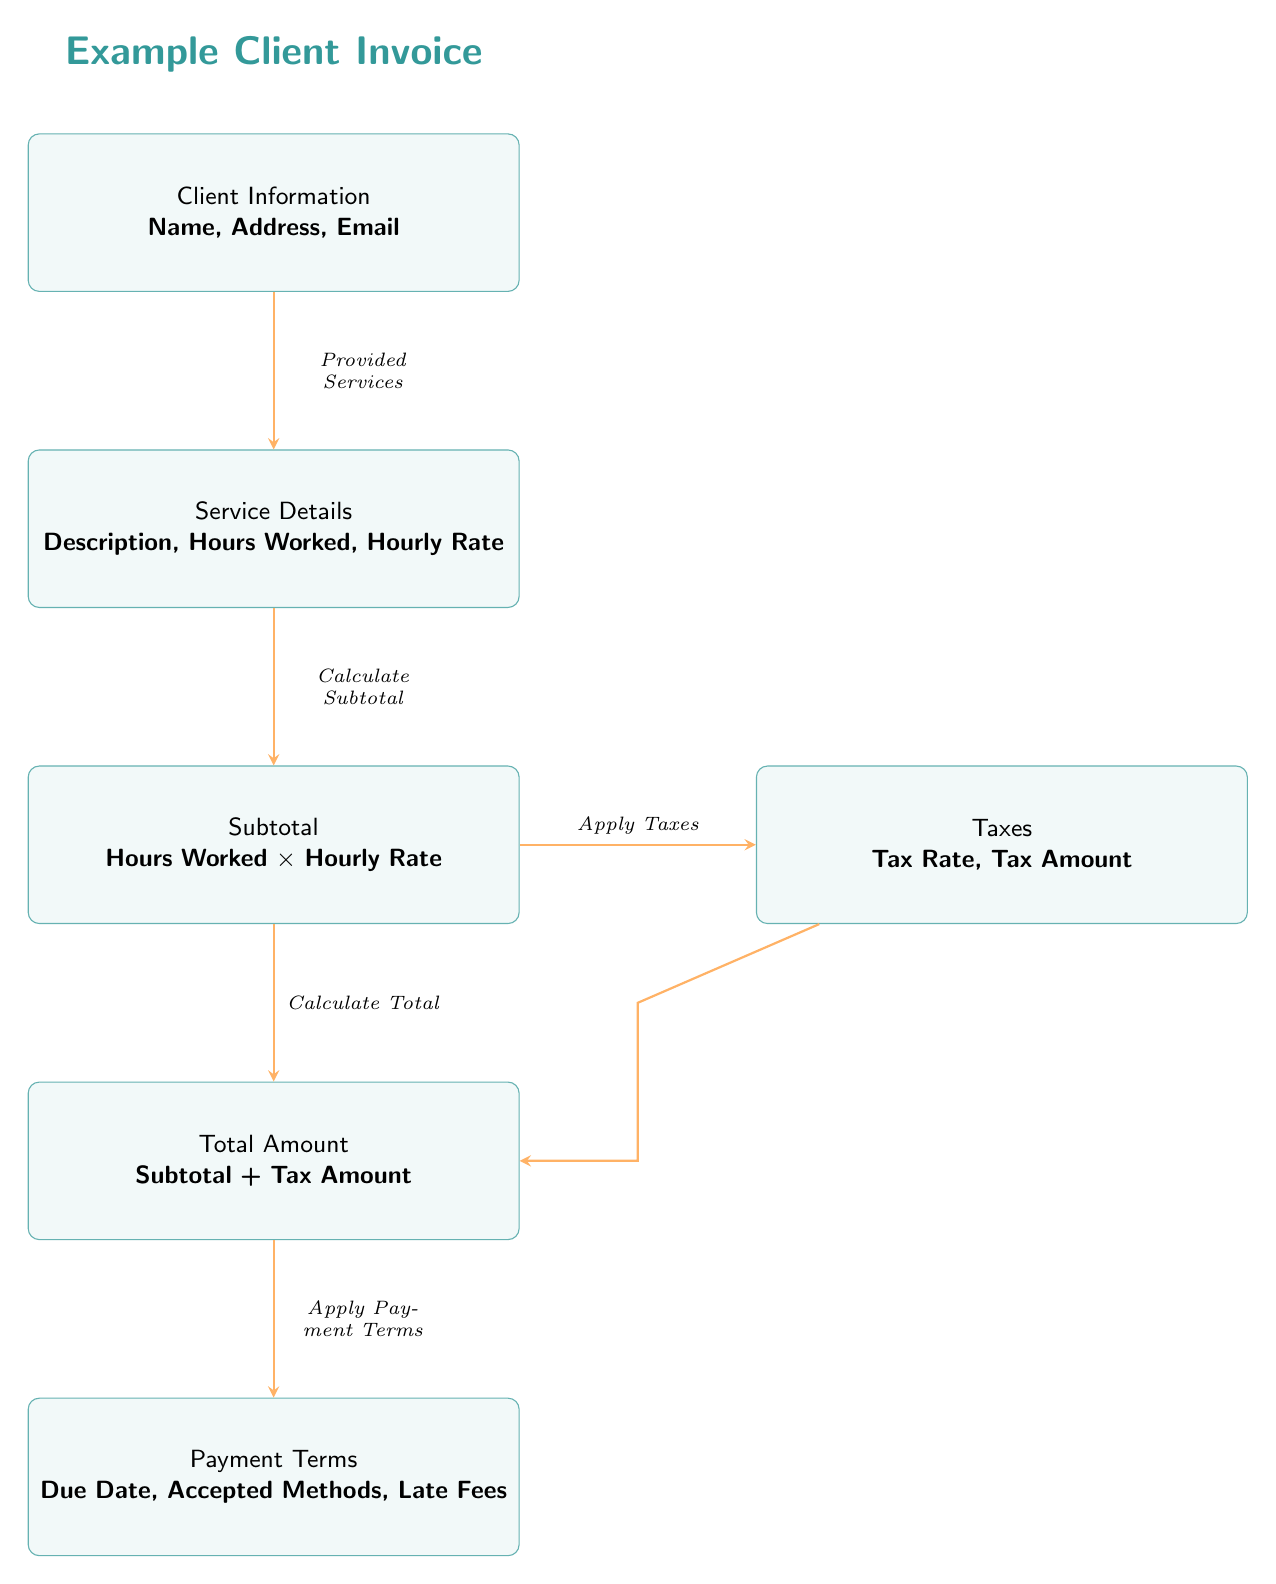What is the first section of the invoice? The first section of the invoice is labeled "Client Information". It is positioned at the top of the diagram and contains details that identify the client.
Answer: Client Information How many nodes are in the diagram? The diagram contains a total of six nodes, each representing a distinct section of the invoice. These nodes include Client Information, Service Details, Subtotal, Taxes, Total Amount, and Payment Terms.
Answer: Six What do we calculate after service details? After the service details, we calculate the subtotal. This step involves determining the total amount earned for the hours worked based on the hourly rate.
Answer: Subtotal Which node applies taxes? The "Taxes" node applies taxes to the subtotal. It is connected to the subtotal node and indicates the tax rate and amount that need to be assessed.
Answer: Taxes What is combined to determine the total amount? The total amount is calculated by combining the subtotal and the tax amount. This process adds the tax calculated from the subtotal to arrive at the final total due for the services rendered.
Answer: Subtotal + Tax Amount What section outlines the due date? The due date is outlined in the "Payment Terms" section. This part specifies when the payment must be made along with accepted payment methods and penalties for late fees.
Answer: Payment Terms What does the arrow between "Subtotal" and "Total Amount" indicate? The arrow indicates that the total amount calculation relies on the subtotal, meaning the total is derived from the subtotal amount, after applying taxes.
Answer: Calculate Total What relationship exists between "Taxes" and "Total Amount"? The relationship is that the "Taxes" node contributes to the calculation of the "Total Amount". The total amount includes both the subtotal and the calculated tax.
Answer: Apply Taxes What additional information is included in client information? The client information typically includes the client's name, address, and email, as shown in the node’s description.
Answer: Name, Address, Email 